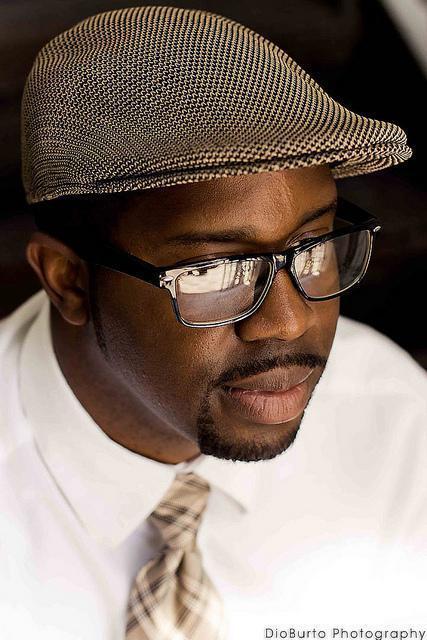How many benches are there?
Give a very brief answer. 0. 